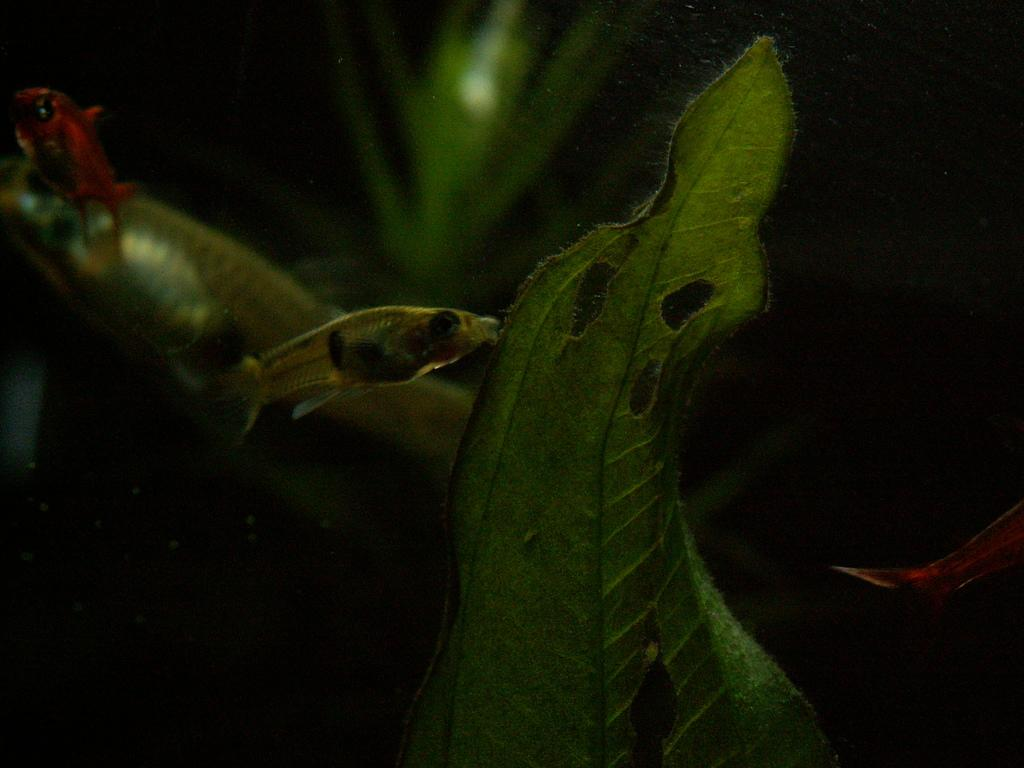What animals are present in the image? There is a fish and a snake in the image. What type of plant material is visible in the image? There is a leaf in the image. What is the color of the background in the image? The background of the image is dark. Reasoning: Let's think step by step by following the given guidelines to produce the conversation. We start by identifying the main subjects in the image, which are the fish and the snake. Then, we mention the leaf as another object present in the image. Finally, we describe the background color, which is dark. Each question is designed to elicit a specific detail about the image that is known from the provided facts. Absurd Question/Answer: What type of whip is being used by the queen in the image? There is no queen or whip present in the image; it only features a fish, a snake, and a leaf. 